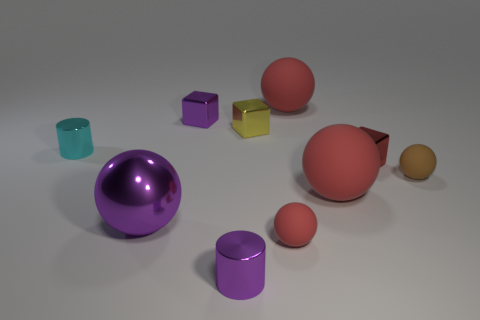How does the lighting in the image affect the appearance of the objects? The lighting in the image is soft and appears to be coming from the upper right, casting subtle shadows to the lower left of the objects. It accentuates the three-dimensionality of each object and gives a sense of depth to the scene. The lighting also produces gentle reflections on the shinier surfaces, further highlighting their geometric properties. 